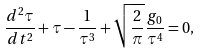<formula> <loc_0><loc_0><loc_500><loc_500>\frac { d ^ { 2 } \tau } { d t ^ { 2 } } + \tau - \frac { 1 } { \tau ^ { 3 } } + \sqrt { \frac { 2 } { \pi } } \frac { g _ { 0 } } { \tau ^ { 4 } } = 0 ,</formula> 